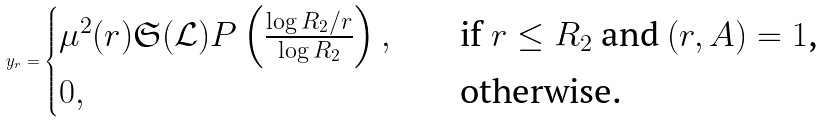Convert formula to latex. <formula><loc_0><loc_0><loc_500><loc_500>y _ { r } = \begin{cases} \mu ^ { 2 } ( r ) \mathfrak { S } ( \mathcal { L } ) P \left ( \frac { \log { R _ { 2 } / r } } { \log { R _ { 2 } } } \right ) , \quad & \text {if $r\leq R_{2}$ and $(r,A)=1$,} \\ 0 , & \text {otherwise.} \end{cases}</formula> 